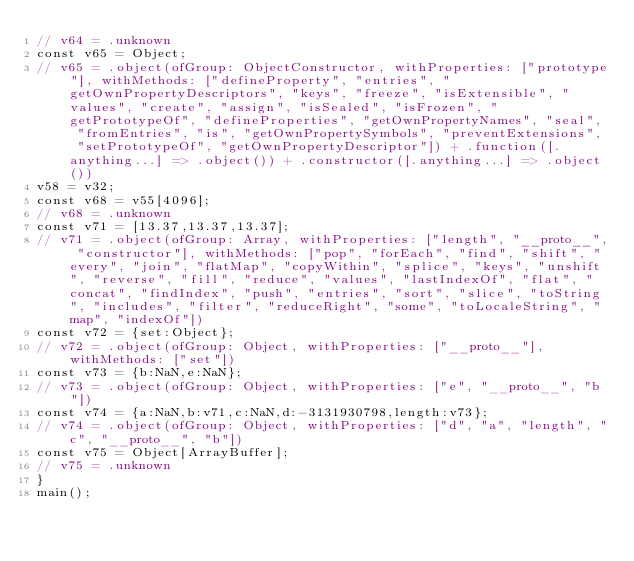Convert code to text. <code><loc_0><loc_0><loc_500><loc_500><_JavaScript_>// v64 = .unknown
const v65 = Object;
// v65 = .object(ofGroup: ObjectConstructor, withProperties: ["prototype"], withMethods: ["defineProperty", "entries", "getOwnPropertyDescriptors", "keys", "freeze", "isExtensible", "values", "create", "assign", "isSealed", "isFrozen", "getPrototypeOf", "defineProperties", "getOwnPropertyNames", "seal", "fromEntries", "is", "getOwnPropertySymbols", "preventExtensions", "setPrototypeOf", "getOwnPropertyDescriptor"]) + .function([.anything...] => .object()) + .constructor([.anything...] => .object())
v58 = v32;
const v68 = v55[4096];
// v68 = .unknown
const v71 = [13.37,13.37,13.37];
// v71 = .object(ofGroup: Array, withProperties: ["length", "__proto__", "constructor"], withMethods: ["pop", "forEach", "find", "shift", "every", "join", "flatMap", "copyWithin", "splice", "keys", "unshift", "reverse", "fill", "reduce", "values", "lastIndexOf", "flat", "concat", "findIndex", "push", "entries", "sort", "slice", "toString", "includes", "filter", "reduceRight", "some", "toLocaleString", "map", "indexOf"])
const v72 = {set:Object};
// v72 = .object(ofGroup: Object, withProperties: ["__proto__"], withMethods: ["set"])
const v73 = {b:NaN,e:NaN};
// v73 = .object(ofGroup: Object, withProperties: ["e", "__proto__", "b"])
const v74 = {a:NaN,b:v71,c:NaN,d:-3131930798,length:v73};
// v74 = .object(ofGroup: Object, withProperties: ["d", "a", "length", "c", "__proto__", "b"])
const v75 = Object[ArrayBuffer];
// v75 = .unknown
}
main();

</code> 